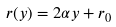Convert formula to latex. <formula><loc_0><loc_0><loc_500><loc_500>r ( y ) = 2 \alpha y + r _ { 0 }</formula> 